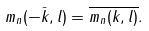Convert formula to latex. <formula><loc_0><loc_0><loc_500><loc_500>m _ { n } ( - \bar { k } , l ) = \overline { m _ { n } ( k , l ) } .</formula> 